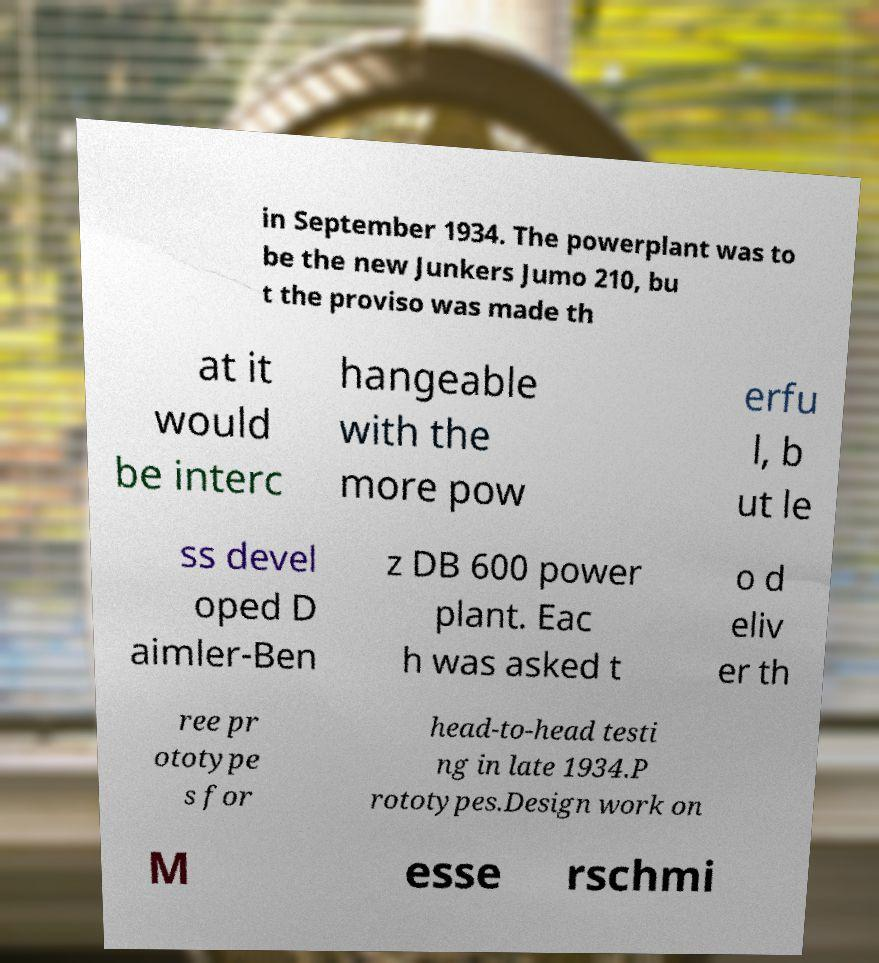I need the written content from this picture converted into text. Can you do that? in September 1934. The powerplant was to be the new Junkers Jumo 210, bu t the proviso was made th at it would be interc hangeable with the more pow erfu l, b ut le ss devel oped D aimler-Ben z DB 600 power plant. Eac h was asked t o d eliv er th ree pr ototype s for head-to-head testi ng in late 1934.P rototypes.Design work on M esse rschmi 